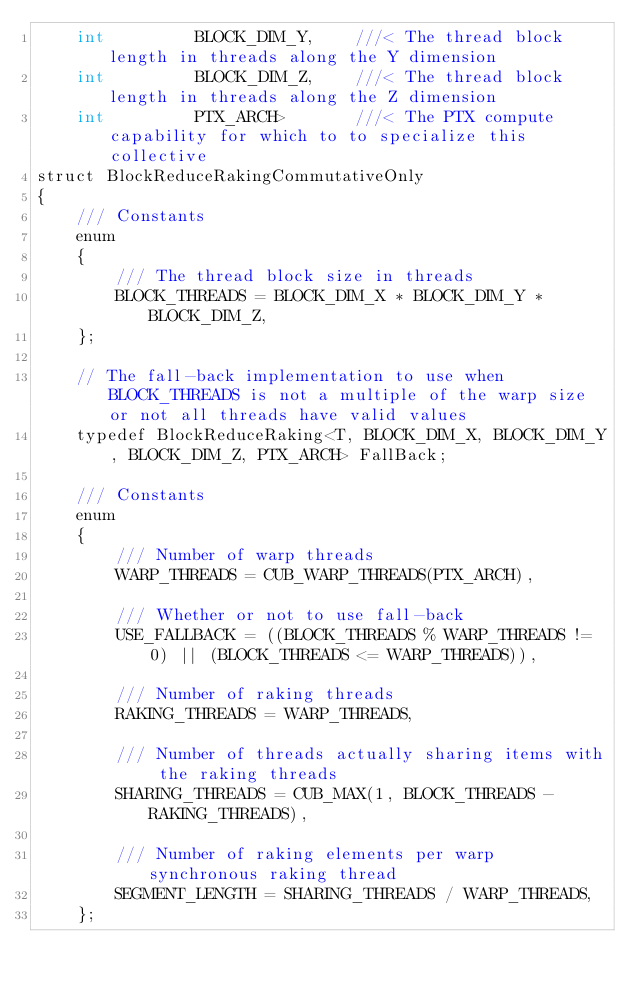<code> <loc_0><loc_0><loc_500><loc_500><_Cuda_>    int         BLOCK_DIM_Y,    ///< The thread block length in threads along the Y dimension
    int         BLOCK_DIM_Z,    ///< The thread block length in threads along the Z dimension
    int         PTX_ARCH>       ///< The PTX compute capability for which to to specialize this collective
struct BlockReduceRakingCommutativeOnly
{
    /// Constants
    enum
    {
        /// The thread block size in threads
        BLOCK_THREADS = BLOCK_DIM_X * BLOCK_DIM_Y * BLOCK_DIM_Z,
    };

    // The fall-back implementation to use when BLOCK_THREADS is not a multiple of the warp size or not all threads have valid values
    typedef BlockReduceRaking<T, BLOCK_DIM_X, BLOCK_DIM_Y, BLOCK_DIM_Z, PTX_ARCH> FallBack;

    /// Constants
    enum
    {
        /// Number of warp threads
        WARP_THREADS = CUB_WARP_THREADS(PTX_ARCH),

        /// Whether or not to use fall-back
        USE_FALLBACK = ((BLOCK_THREADS % WARP_THREADS != 0) || (BLOCK_THREADS <= WARP_THREADS)),

        /// Number of raking threads
        RAKING_THREADS = WARP_THREADS,

        /// Number of threads actually sharing items with the raking threads
        SHARING_THREADS = CUB_MAX(1, BLOCK_THREADS - RAKING_THREADS),

        /// Number of raking elements per warp synchronous raking thread
        SEGMENT_LENGTH = SHARING_THREADS / WARP_THREADS,
    };
</code> 